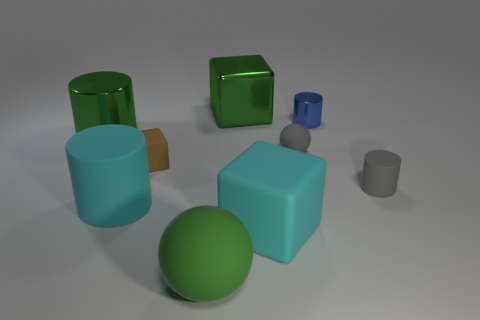Subtract 1 cylinders. How many cylinders are left? 3 Add 1 brown cubes. How many objects exist? 10 Subtract all blocks. How many objects are left? 6 Add 2 blue metal cylinders. How many blue metal cylinders exist? 3 Subtract 0 yellow balls. How many objects are left? 9 Subtract all large gray things. Subtract all large cyan cylinders. How many objects are left? 8 Add 3 big rubber things. How many big rubber things are left? 6 